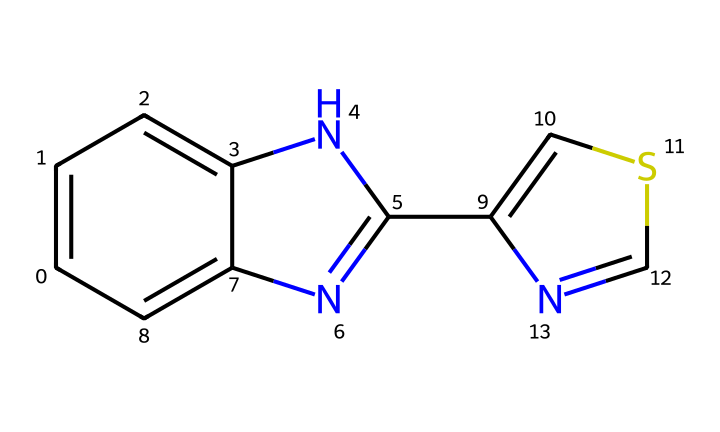What is the molecular formula of thiabendazole? To determine the molecular formula from the SMILES representation, we can break it down and count the different atoms present. This specific structure contains carbon, nitrogen, and sulfur atoms. The total count gives us the molecular formula of C10H10N4S.
Answer: C10H10N4S How many nitrogen atoms are present in the structure? By examining the SMILES representation, we can directly count the nitrogen atoms. There are four nitrogen symbols (N) present.
Answer: 4 What type of compound is this chemical categorized as? Thiabendazole is identified as a benzimidazole derivative, a common group of fungicides. Specifically, it has a heterocyclic ring structure that contributes to its classification.
Answer: fungicide Which feature of the chemical indicates its fungicidal properties? The presence of the benzimidazole ring in the structure is a key feature that is associated with antifungal activity. This ring structure interacts effectively with fungal cells, inhibiting their growth.
Answer: benzimidazole ring What is the total number of rings present in the molecular structure? In the SMILES, we can identify the connectivity of the atoms, leading to the identification of two fused rings in the structure. This indicates the presence of ring systems in its molecular architecture.
Answer: 2 What potential effect does this compound have on fruit preservation? Thiabendazole acts as a fungicide, effectively preventing mold growth on fruit, which prolongs its freshness and shelf life. This effect on preventing spoilage is crucial for preserving fruit quality during storage and transportation.
Answer: prevents mold growth 